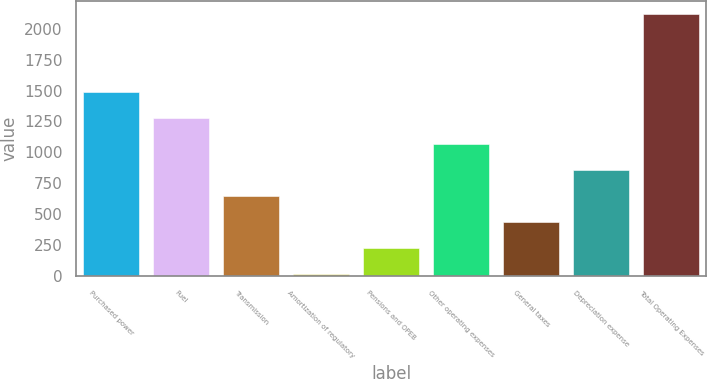Convert chart. <chart><loc_0><loc_0><loc_500><loc_500><bar_chart><fcel>Purchased power<fcel>Fuel<fcel>Transmission<fcel>Amortization of regulatory<fcel>Pensions and OPEB<fcel>Other operating expenses<fcel>General taxes<fcel>Depreciation expense<fcel>Total Operating Expenses<nl><fcel>1490.3<fcel>1280.4<fcel>650.7<fcel>21<fcel>230.9<fcel>1070.5<fcel>440.8<fcel>860.6<fcel>2120<nl></chart> 